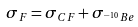Convert formula to latex. <formula><loc_0><loc_0><loc_500><loc_500>\sigma _ { F } = \sigma _ { C F } + \sigma _ { ^ { - \, 1 0 } B e }</formula> 